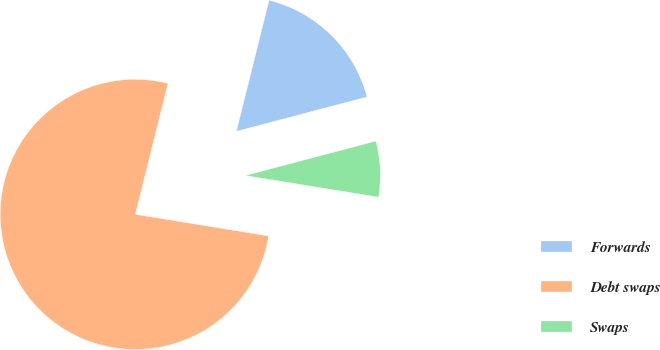Convert chart to OTSL. <chart><loc_0><loc_0><loc_500><loc_500><pie_chart><fcel>Forwards<fcel>Debt swaps<fcel>Swaps<nl><fcel>17.01%<fcel>76.33%<fcel>6.66%<nl></chart> 